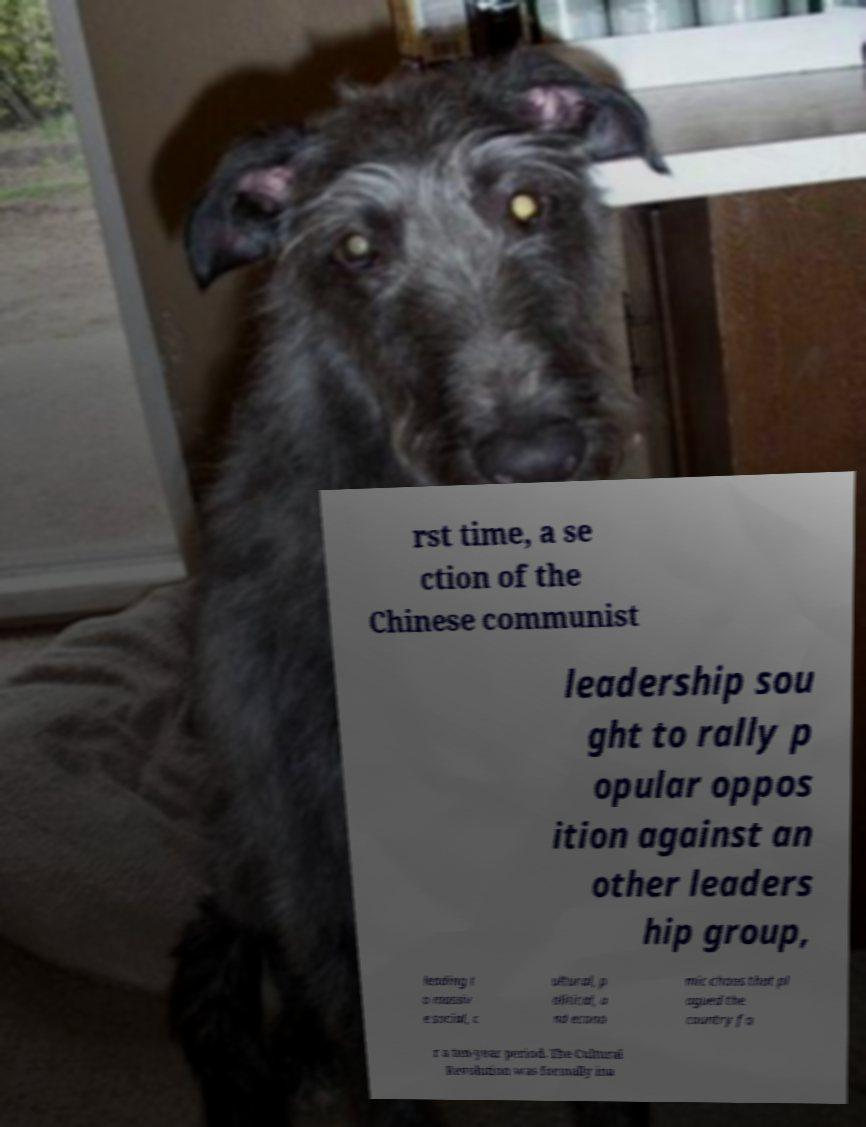There's text embedded in this image that I need extracted. Can you transcribe it verbatim? rst time, a se ction of the Chinese communist leadership sou ght to rally p opular oppos ition against an other leaders hip group, leading t o massiv e social, c ultural, p olitical, a nd econo mic chaos that pl agued the country fo r a ten-year period. The Cultural Revolution was formally ina 